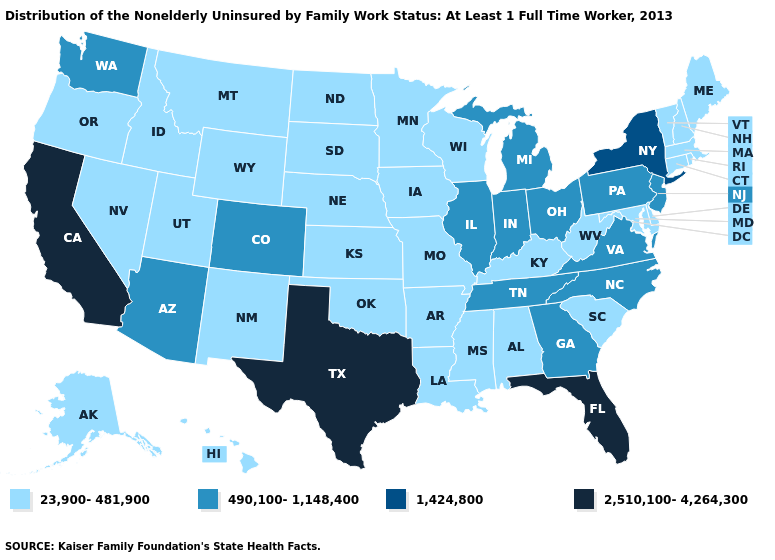Does the map have missing data?
Give a very brief answer. No. How many symbols are there in the legend?
Be succinct. 4. What is the value of Wisconsin?
Give a very brief answer. 23,900-481,900. Which states have the lowest value in the USA?
Concise answer only. Alabama, Alaska, Arkansas, Connecticut, Delaware, Hawaii, Idaho, Iowa, Kansas, Kentucky, Louisiana, Maine, Maryland, Massachusetts, Minnesota, Mississippi, Missouri, Montana, Nebraska, Nevada, New Hampshire, New Mexico, North Dakota, Oklahoma, Oregon, Rhode Island, South Carolina, South Dakota, Utah, Vermont, West Virginia, Wisconsin, Wyoming. Does Virginia have a lower value than Florida?
Answer briefly. Yes. Among the states that border Iowa , does Nebraska have the lowest value?
Short answer required. Yes. Does the map have missing data?
Answer briefly. No. What is the value of New York?
Write a very short answer. 1,424,800. What is the lowest value in the USA?
Quick response, please. 23,900-481,900. Name the states that have a value in the range 1,424,800?
Short answer required. New York. Does the first symbol in the legend represent the smallest category?
Write a very short answer. Yes. Does California have the lowest value in the USA?
Quick response, please. No. Does Kentucky have the lowest value in the South?
Answer briefly. Yes. Name the states that have a value in the range 490,100-1,148,400?
Answer briefly. Arizona, Colorado, Georgia, Illinois, Indiana, Michigan, New Jersey, North Carolina, Ohio, Pennsylvania, Tennessee, Virginia, Washington. 